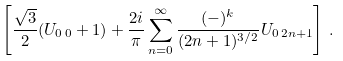Convert formula to latex. <formula><loc_0><loc_0><loc_500><loc_500>\left [ \frac { \sqrt { 3 } } { 2 } ( U _ { 0 \, 0 } + 1 ) + \frac { 2 i } { \pi } \sum _ { n = 0 } ^ { \infty } \frac { ( - ) ^ { k } } { ( 2 n + 1 ) ^ { 3 / 2 } } U _ { 0 \, 2 n + 1 } \right ] \, .</formula> 